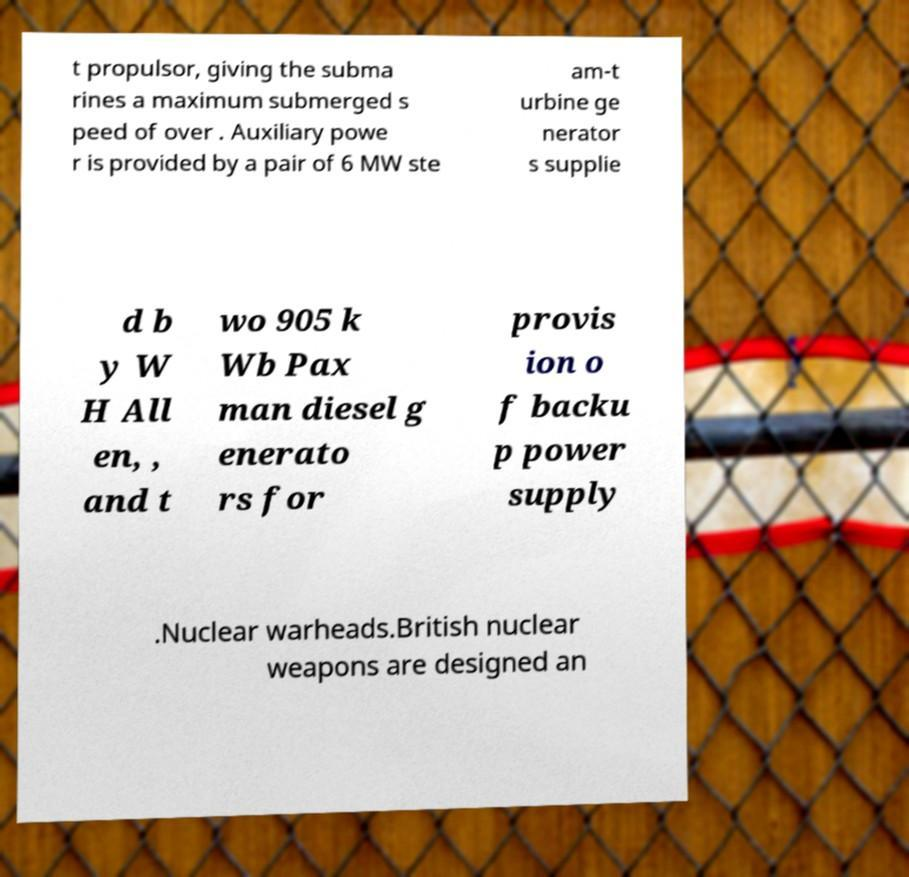Can you read and provide the text displayed in the image?This photo seems to have some interesting text. Can you extract and type it out for me? t propulsor, giving the subma rines a maximum submerged s peed of over . Auxiliary powe r is provided by a pair of 6 MW ste am-t urbine ge nerator s supplie d b y W H All en, , and t wo 905 k Wb Pax man diesel g enerato rs for provis ion o f backu p power supply .Nuclear warheads.British nuclear weapons are designed an 